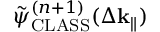Convert formula to latex. <formula><loc_0><loc_0><loc_500><loc_500>\tilde { \psi } _ { C L A S S } ^ { ( n + 1 ) } ( \Delta k _ { \| } )</formula> 